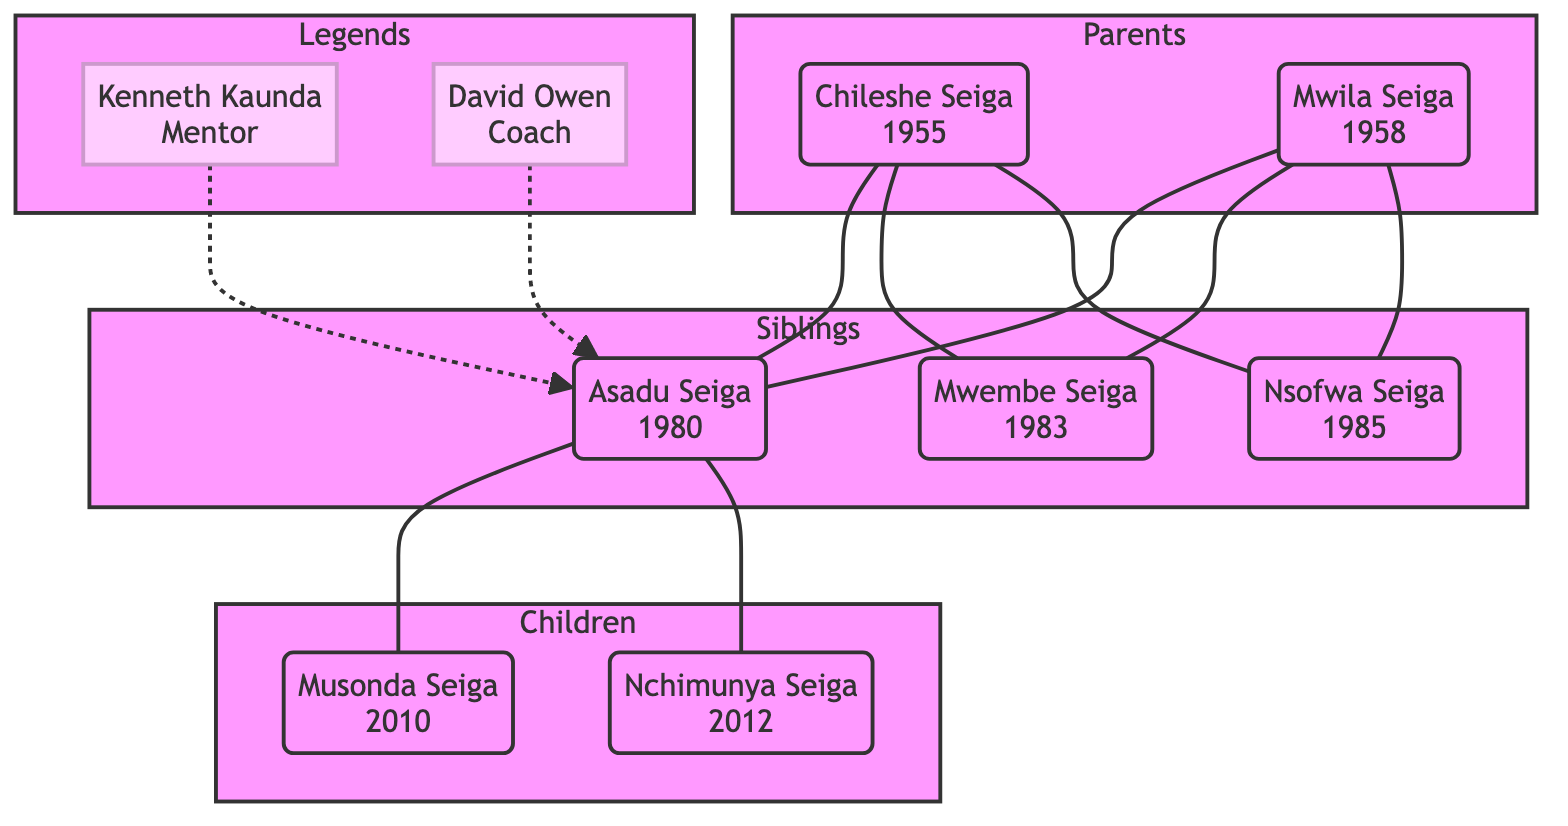What is the birth year of Asadu Seiga? The diagram shows the node for Asadu Seiga with the birth year of 1980 directly associated with his name.
Answer: 1980 Who is the father of Asadu Seiga? The diagram connects the node for Asadu Seiga to a parent node labeled Chileshe Seiga, indicating that he is the father.
Answer: Chileshe Seiga How many children does Asadu Seiga have? The diagram shows two nodes branching from Asadu Seiga’s node, representing his children (Musonda Seiga and Nchimunya Seiga). Thus, there are two children.
Answer: 2 What role did Kenneth Kaunda have in relation to Asadu Seiga? The diagram depicts a dashed line connecting the node of Kenneth Kaunda to Asadu Seiga, indicating that he served as a mentor.
Answer: Mentor Which sibling of Asadu Seiga is a cricket commentator? The diagram illustrates that Mwembe Seiga is a sibling of Asadu Seiga, and the career highlights associated with his node mention that he is a cricket commentator.
Answer: Mwembe Seiga What is a notable achievement of Mwila Seiga? The diagram points out Mwila Seiga’s node with the achievement of being a long-standing supporter and promoter of women's cricket in Zambia.
Answer: Promoter of women's cricket Which child of Asadu Seiga was born in 2012? In the diagram, the node for Nchimunya Seiga is associated with the birth year 2012, confirming this information as it points to him being one of Asadu's children.
Answer: Nchimunya Seiga How many siblings does Asadu Seiga have? The diagram lists two nodes under the siblings subgraph (Mwembe Seiga and Nsofwa Seiga), indicating that Asadu has two siblings.
Answer: 2 What is the connection detail for David Owen? The diagram presents a dashed connection from David Owen to Asadu Seiga, with the details stating he was a coach who worked extensively with Zambia's national team.
Answer: Coach 